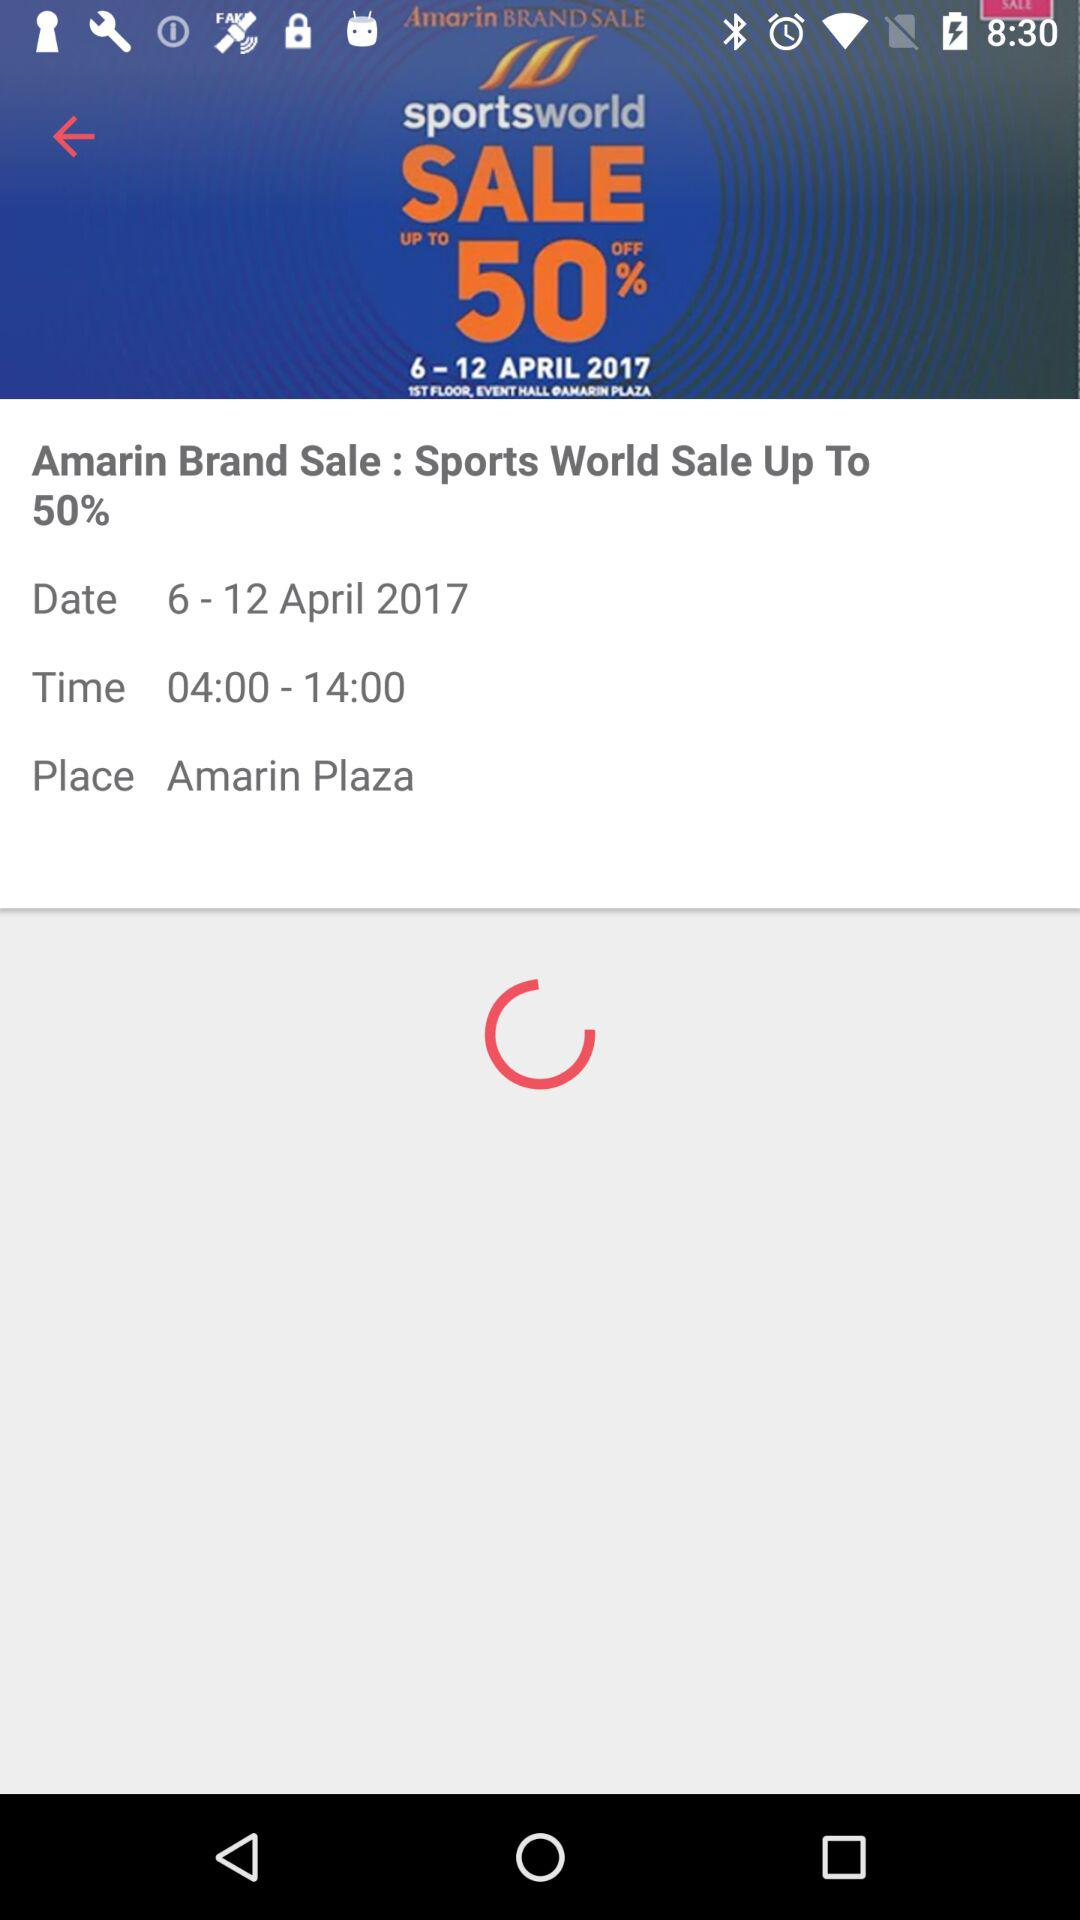How much of the discount percentage is on sale? The discount is up to 50%. 